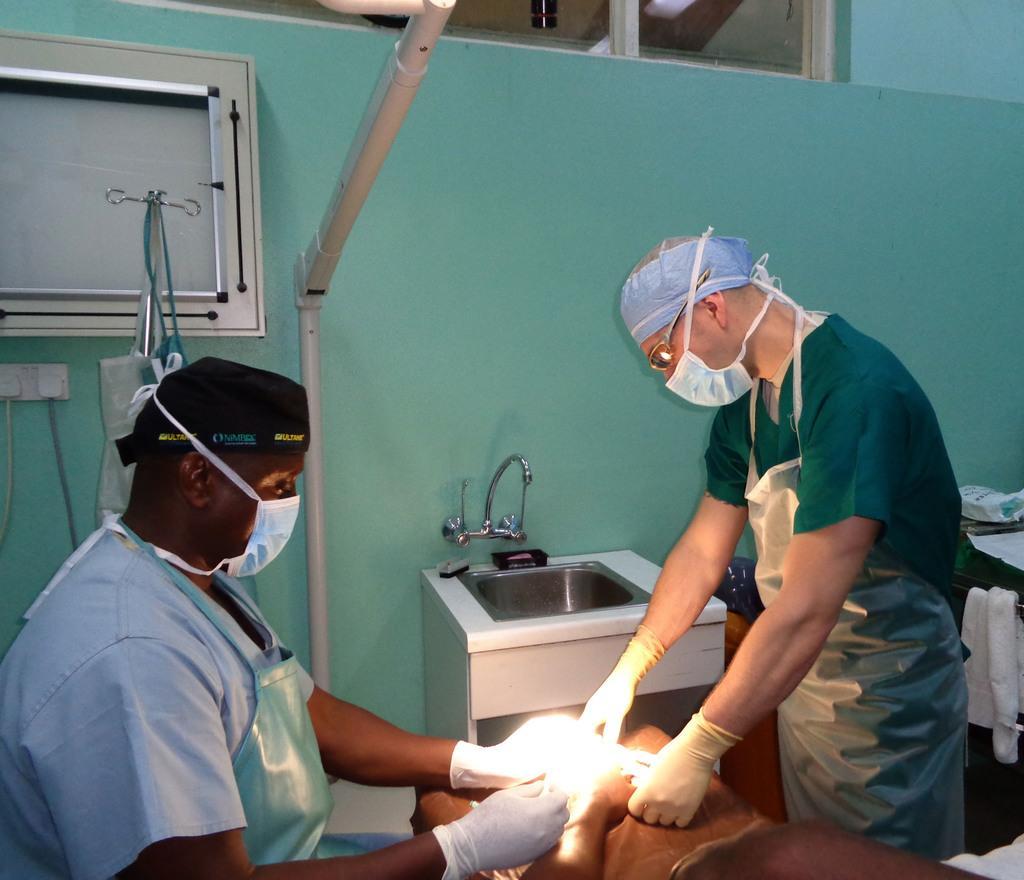Could you give a brief overview of what you see in this image? In this image we can see two doctors with aprons and masks. One of the doctor is wearing the glasses. Image also consists of a sink, hand towel, switch board with plugs, some bags and also the glass window. We can also see the board to the wall. 